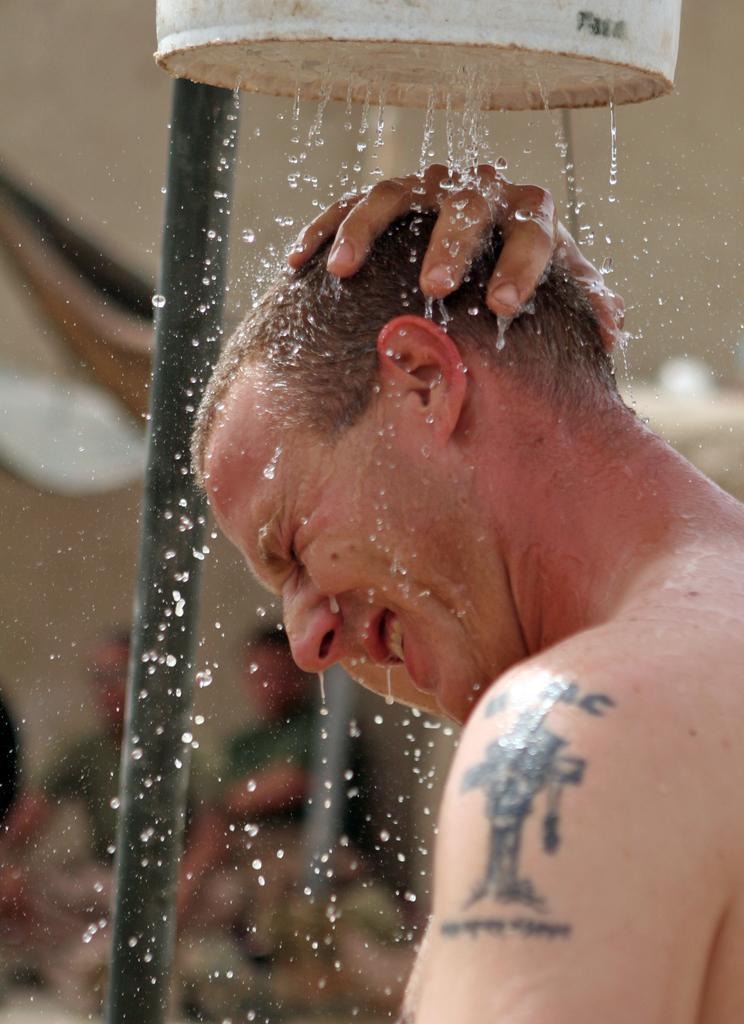Could you give a brief overview of what you see in this image? On the right side, there is a person keeping a hand on his head, having a tattoo on his shoulder and standing under a shower, which is emitting water drops. In the background, there is a pole and there are two persons. And the background is blurred. 